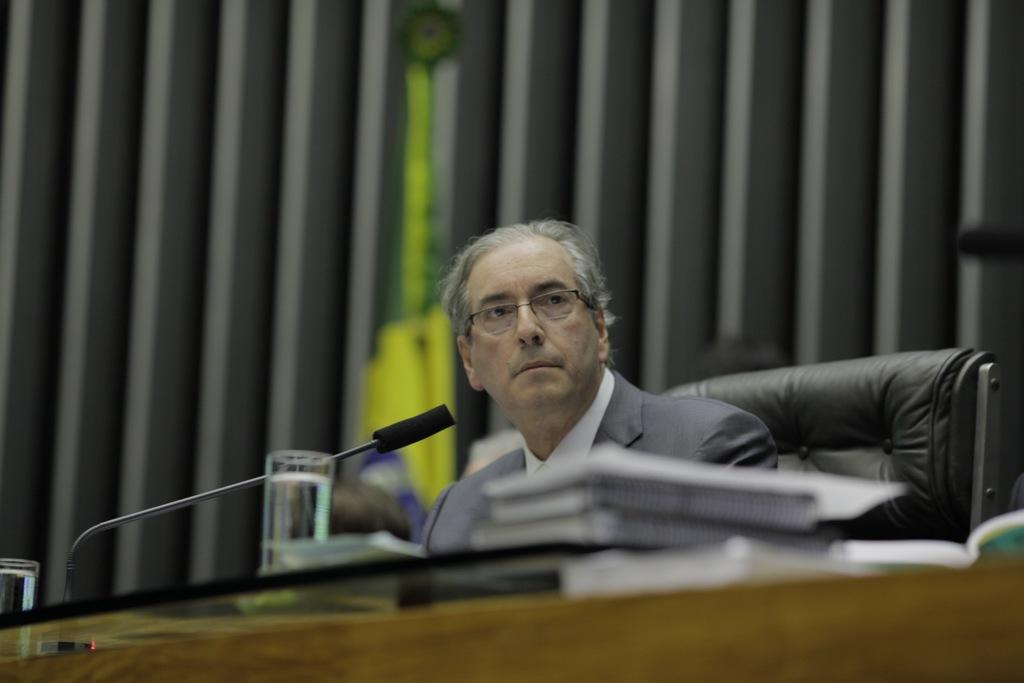In one or two sentences, can you explain what this image depicts? In this image I can see a man is sitting on a chair. I can also see a mic and few glasses. 